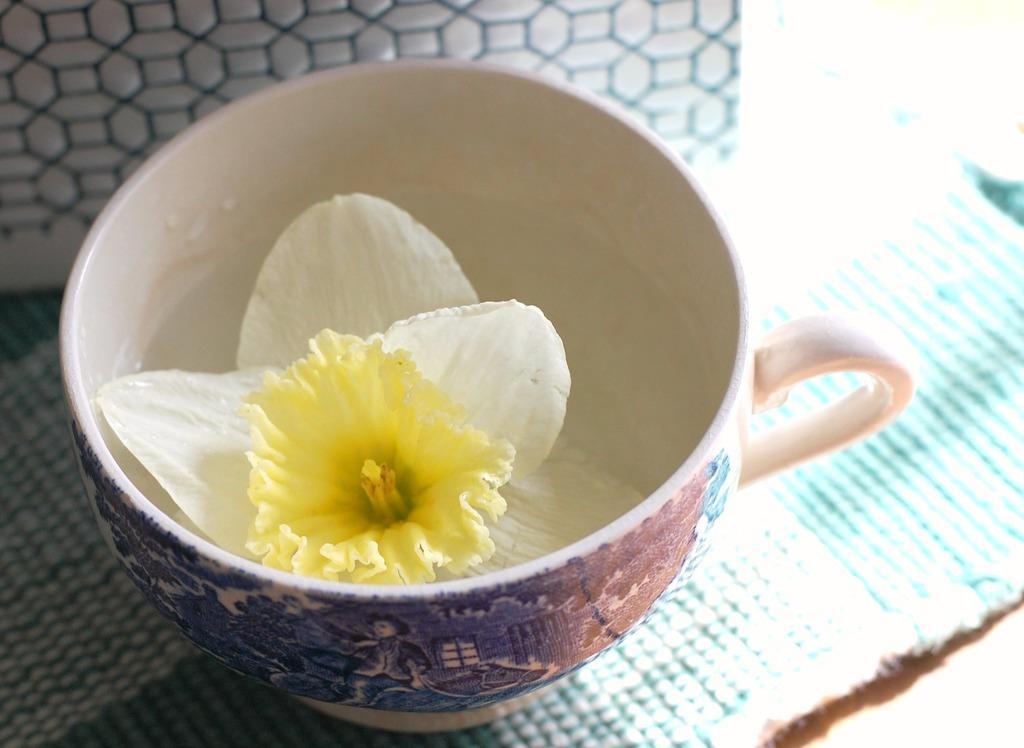Describe this image in one or two sentences. Here in this picture we can see a cup present over a place and in that cup we can see a flower present and we can also see its pollen grains present over there. 